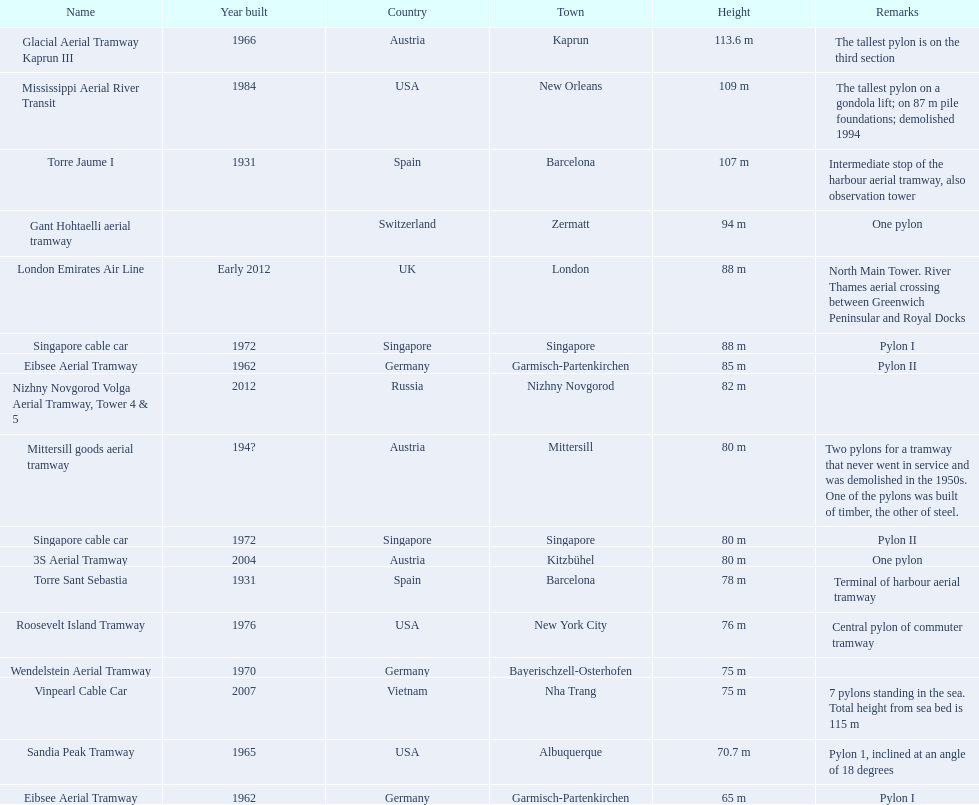How many pylons are at least 80 meters tall? 11. Parse the full table. {'header': ['Name', 'Year built', 'Country', 'Town', 'Height', 'Remarks'], 'rows': [['Glacial Aerial Tramway Kaprun III', '1966', 'Austria', 'Kaprun', '113.6 m', 'The tallest pylon is on the third section'], ['Mississippi Aerial River Transit', '1984', 'USA', 'New Orleans', '109 m', 'The tallest pylon on a gondola lift; on 87 m pile foundations; demolished 1994'], ['Torre Jaume I', '1931', 'Spain', 'Barcelona', '107 m', 'Intermediate stop of the harbour aerial tramway, also observation tower'], ['Gant Hohtaelli aerial tramway', '', 'Switzerland', 'Zermatt', '94 m', 'One pylon'], ['London Emirates Air Line', 'Early 2012', 'UK', 'London', '88 m', 'North Main Tower. River Thames aerial crossing between Greenwich Peninsular and Royal Docks'], ['Singapore cable car', '1972', 'Singapore', 'Singapore', '88 m', 'Pylon I'], ['Eibsee Aerial Tramway', '1962', 'Germany', 'Garmisch-Partenkirchen', '85 m', 'Pylon II'], ['Nizhny Novgorod Volga Aerial Tramway, Tower 4 & 5', '2012', 'Russia', 'Nizhny Novgorod', '82 m', ''], ['Mittersill goods aerial tramway', '194?', 'Austria', 'Mittersill', '80 m', 'Two pylons for a tramway that never went in service and was demolished in the 1950s. One of the pylons was built of timber, the other of steel.'], ['Singapore cable car', '1972', 'Singapore', 'Singapore', '80 m', 'Pylon II'], ['3S Aerial Tramway', '2004', 'Austria', 'Kitzbühel', '80 m', 'One pylon'], ['Torre Sant Sebastia', '1931', 'Spain', 'Barcelona', '78 m', 'Terminal of harbour aerial tramway'], ['Roosevelt Island Tramway', '1976', 'USA', 'New York City', '76 m', 'Central pylon of commuter tramway'], ['Wendelstein Aerial Tramway', '1970', 'Germany', 'Bayerischzell-Osterhofen', '75 m', ''], ['Vinpearl Cable Car', '2007', 'Vietnam', 'Nha Trang', '75 m', '7 pylons standing in the sea. Total height from sea bed is 115 m'], ['Sandia Peak Tramway', '1965', 'USA', 'Albuquerque', '70.7 m', 'Pylon 1, inclined at an angle of 18 degrees'], ['Eibsee Aerial Tramway', '1962', 'Germany', 'Garmisch-Partenkirchen', '65 m', 'Pylon I']]} 